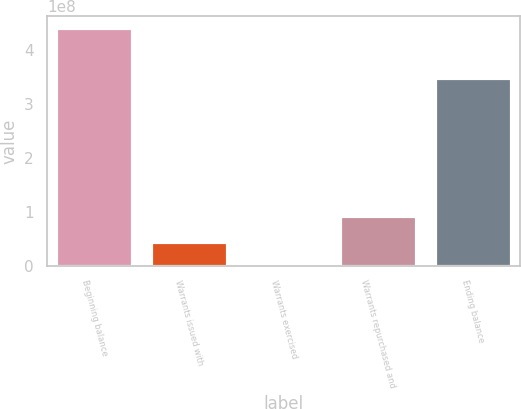<chart> <loc_0><loc_0><loc_500><loc_500><bar_chart><fcel>Beginning balance<fcel>Warrants issued with<fcel>Warrants exercised<fcel>Warrants repurchased and<fcel>Ending balance<nl><fcel>4.39809e+08<fcel>4.4e+07<fcel>21208<fcel>9.19736e+07<fcel>3.47933e+08<nl></chart> 